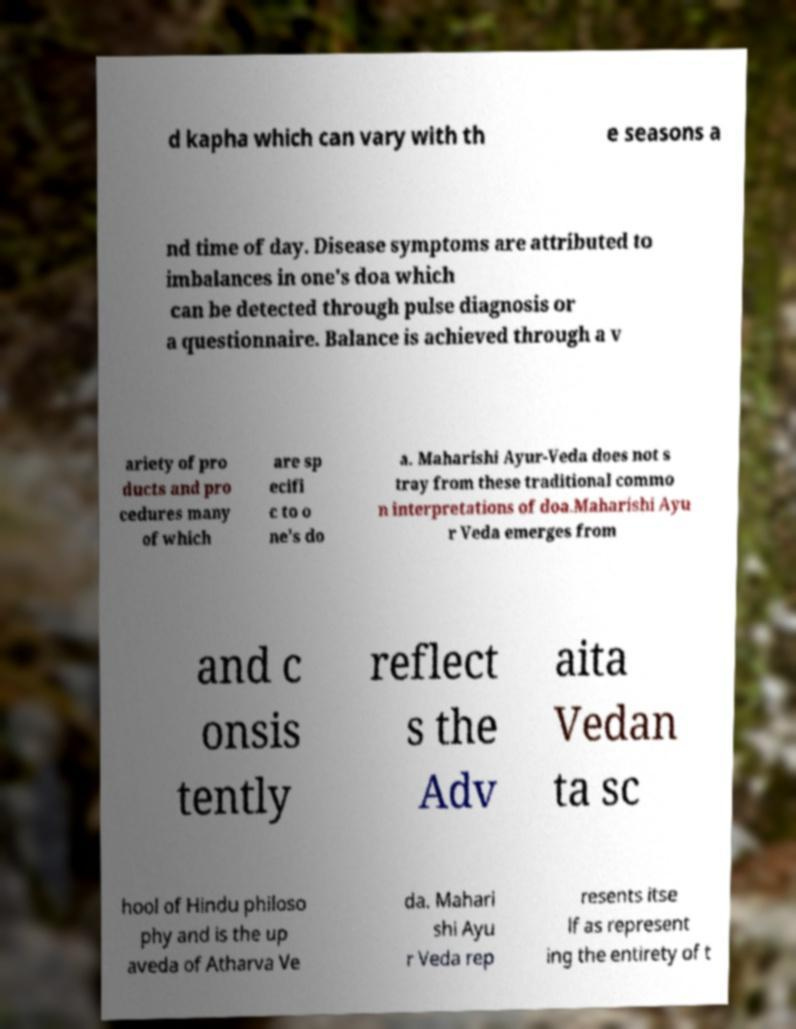Please read and relay the text visible in this image. What does it say? d kapha which can vary with th e seasons a nd time of day. Disease symptoms are attributed to imbalances in one's doa which can be detected through pulse diagnosis or a questionnaire. Balance is achieved through a v ariety of pro ducts and pro cedures many of which are sp ecifi c to o ne's do a. Maharishi Ayur-Veda does not s tray from these traditional commo n interpretations of doa.Maharishi Ayu r Veda emerges from and c onsis tently reflect s the Adv aita Vedan ta sc hool of Hindu philoso phy and is the up aveda of Atharva Ve da. Mahari shi Ayu r Veda rep resents itse lf as represent ing the entirety of t 